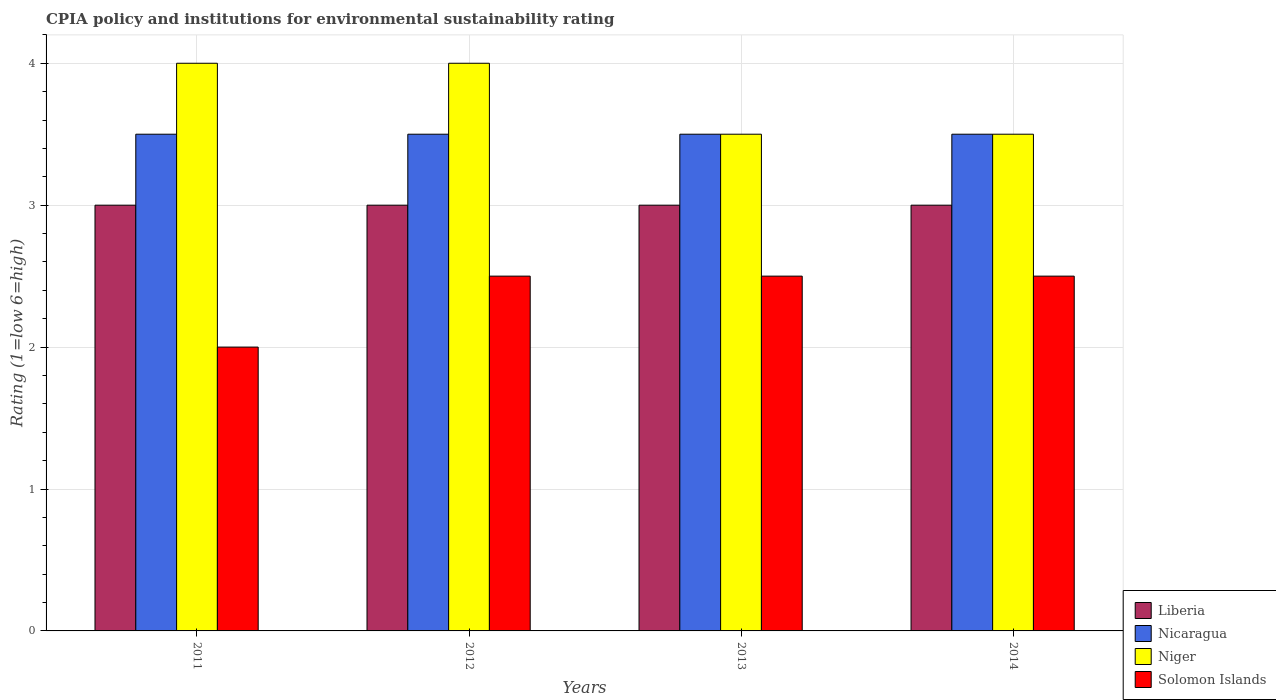How many different coloured bars are there?
Make the answer very short. 4. How many bars are there on the 4th tick from the left?
Keep it short and to the point. 4. What is the label of the 3rd group of bars from the left?
Offer a terse response. 2013. In how many cases, is the number of bars for a given year not equal to the number of legend labels?
Your answer should be compact. 0. What is the CPIA rating in Nicaragua in 2012?
Your answer should be very brief. 3.5. What is the average CPIA rating in Niger per year?
Keep it short and to the point. 3.75. What is the difference between the highest and the lowest CPIA rating in Solomon Islands?
Your response must be concise. 0.5. Is the sum of the CPIA rating in Solomon Islands in 2011 and 2013 greater than the maximum CPIA rating in Nicaragua across all years?
Offer a very short reply. Yes. What does the 3rd bar from the left in 2012 represents?
Your answer should be very brief. Niger. What does the 1st bar from the right in 2012 represents?
Offer a very short reply. Solomon Islands. How many years are there in the graph?
Give a very brief answer. 4. Are the values on the major ticks of Y-axis written in scientific E-notation?
Your answer should be very brief. No. How many legend labels are there?
Provide a short and direct response. 4. How are the legend labels stacked?
Provide a succinct answer. Vertical. What is the title of the graph?
Provide a succinct answer. CPIA policy and institutions for environmental sustainability rating. What is the label or title of the Y-axis?
Offer a terse response. Rating (1=low 6=high). What is the Rating (1=low 6=high) in Liberia in 2011?
Your answer should be compact. 3. What is the Rating (1=low 6=high) of Nicaragua in 2011?
Provide a short and direct response. 3.5. What is the Rating (1=low 6=high) in Nicaragua in 2012?
Keep it short and to the point. 3.5. What is the Rating (1=low 6=high) in Niger in 2012?
Your response must be concise. 4. What is the Rating (1=low 6=high) of Solomon Islands in 2012?
Provide a short and direct response. 2.5. What is the Rating (1=low 6=high) of Liberia in 2013?
Offer a terse response. 3. What is the Rating (1=low 6=high) in Nicaragua in 2013?
Your answer should be compact. 3.5. What is the Rating (1=low 6=high) in Niger in 2013?
Provide a succinct answer. 3.5. What is the Rating (1=low 6=high) of Nicaragua in 2014?
Make the answer very short. 3.5. What is the Rating (1=low 6=high) of Solomon Islands in 2014?
Ensure brevity in your answer.  2.5. Across all years, what is the maximum Rating (1=low 6=high) in Liberia?
Your answer should be very brief. 3. Across all years, what is the maximum Rating (1=low 6=high) in Niger?
Ensure brevity in your answer.  4. Across all years, what is the minimum Rating (1=low 6=high) of Nicaragua?
Keep it short and to the point. 3.5. What is the total Rating (1=low 6=high) in Niger in the graph?
Provide a succinct answer. 15. What is the total Rating (1=low 6=high) in Solomon Islands in the graph?
Offer a very short reply. 9.5. What is the difference between the Rating (1=low 6=high) of Liberia in 2011 and that in 2012?
Offer a terse response. 0. What is the difference between the Rating (1=low 6=high) of Solomon Islands in 2011 and that in 2012?
Make the answer very short. -0.5. What is the difference between the Rating (1=low 6=high) in Liberia in 2011 and that in 2013?
Provide a short and direct response. 0. What is the difference between the Rating (1=low 6=high) in Niger in 2011 and that in 2013?
Keep it short and to the point. 0.5. What is the difference between the Rating (1=low 6=high) in Liberia in 2011 and that in 2014?
Your answer should be very brief. 0. What is the difference between the Rating (1=low 6=high) in Niger in 2011 and that in 2014?
Your answer should be compact. 0.5. What is the difference between the Rating (1=low 6=high) of Liberia in 2012 and that in 2013?
Make the answer very short. 0. What is the difference between the Rating (1=low 6=high) in Nicaragua in 2012 and that in 2013?
Give a very brief answer. 0. What is the difference between the Rating (1=low 6=high) in Nicaragua in 2012 and that in 2014?
Make the answer very short. 0. What is the difference between the Rating (1=low 6=high) in Solomon Islands in 2012 and that in 2014?
Provide a succinct answer. 0. What is the difference between the Rating (1=low 6=high) in Liberia in 2011 and the Rating (1=low 6=high) in Niger in 2012?
Ensure brevity in your answer.  -1. What is the difference between the Rating (1=low 6=high) of Nicaragua in 2011 and the Rating (1=low 6=high) of Niger in 2012?
Your answer should be very brief. -0.5. What is the difference between the Rating (1=low 6=high) in Nicaragua in 2011 and the Rating (1=low 6=high) in Solomon Islands in 2012?
Keep it short and to the point. 1. What is the difference between the Rating (1=low 6=high) of Liberia in 2011 and the Rating (1=low 6=high) of Nicaragua in 2013?
Your answer should be very brief. -0.5. What is the difference between the Rating (1=low 6=high) in Liberia in 2011 and the Rating (1=low 6=high) in Solomon Islands in 2013?
Ensure brevity in your answer.  0.5. What is the difference between the Rating (1=low 6=high) in Nicaragua in 2011 and the Rating (1=low 6=high) in Solomon Islands in 2013?
Provide a short and direct response. 1. What is the difference between the Rating (1=low 6=high) of Niger in 2011 and the Rating (1=low 6=high) of Solomon Islands in 2013?
Offer a terse response. 1.5. What is the difference between the Rating (1=low 6=high) in Nicaragua in 2011 and the Rating (1=low 6=high) in Niger in 2014?
Your answer should be compact. 0. What is the difference between the Rating (1=low 6=high) of Nicaragua in 2011 and the Rating (1=low 6=high) of Solomon Islands in 2014?
Provide a short and direct response. 1. What is the difference between the Rating (1=low 6=high) of Niger in 2011 and the Rating (1=low 6=high) of Solomon Islands in 2014?
Offer a very short reply. 1.5. What is the difference between the Rating (1=low 6=high) of Liberia in 2012 and the Rating (1=low 6=high) of Solomon Islands in 2013?
Offer a very short reply. 0.5. What is the difference between the Rating (1=low 6=high) of Nicaragua in 2012 and the Rating (1=low 6=high) of Niger in 2013?
Keep it short and to the point. 0. What is the difference between the Rating (1=low 6=high) of Nicaragua in 2012 and the Rating (1=low 6=high) of Solomon Islands in 2013?
Offer a very short reply. 1. What is the difference between the Rating (1=low 6=high) in Liberia in 2012 and the Rating (1=low 6=high) in Niger in 2014?
Offer a very short reply. -0.5. What is the difference between the Rating (1=low 6=high) of Nicaragua in 2012 and the Rating (1=low 6=high) of Niger in 2014?
Offer a terse response. 0. What is the difference between the Rating (1=low 6=high) of Niger in 2012 and the Rating (1=low 6=high) of Solomon Islands in 2014?
Offer a terse response. 1.5. What is the difference between the Rating (1=low 6=high) in Liberia in 2013 and the Rating (1=low 6=high) in Niger in 2014?
Your answer should be very brief. -0.5. What is the average Rating (1=low 6=high) in Liberia per year?
Give a very brief answer. 3. What is the average Rating (1=low 6=high) of Niger per year?
Make the answer very short. 3.75. What is the average Rating (1=low 6=high) of Solomon Islands per year?
Give a very brief answer. 2.38. In the year 2011, what is the difference between the Rating (1=low 6=high) in Liberia and Rating (1=low 6=high) in Niger?
Your response must be concise. -1. In the year 2011, what is the difference between the Rating (1=low 6=high) of Liberia and Rating (1=low 6=high) of Solomon Islands?
Keep it short and to the point. 1. In the year 2011, what is the difference between the Rating (1=low 6=high) in Nicaragua and Rating (1=low 6=high) in Niger?
Make the answer very short. -0.5. In the year 2011, what is the difference between the Rating (1=low 6=high) in Nicaragua and Rating (1=low 6=high) in Solomon Islands?
Give a very brief answer. 1.5. In the year 2011, what is the difference between the Rating (1=low 6=high) of Niger and Rating (1=low 6=high) of Solomon Islands?
Make the answer very short. 2. In the year 2012, what is the difference between the Rating (1=low 6=high) of Liberia and Rating (1=low 6=high) of Nicaragua?
Ensure brevity in your answer.  -0.5. In the year 2012, what is the difference between the Rating (1=low 6=high) of Liberia and Rating (1=low 6=high) of Niger?
Provide a succinct answer. -1. In the year 2012, what is the difference between the Rating (1=low 6=high) of Nicaragua and Rating (1=low 6=high) of Solomon Islands?
Offer a very short reply. 1. In the year 2013, what is the difference between the Rating (1=low 6=high) of Liberia and Rating (1=low 6=high) of Nicaragua?
Make the answer very short. -0.5. In the year 2013, what is the difference between the Rating (1=low 6=high) of Nicaragua and Rating (1=low 6=high) of Niger?
Your answer should be very brief. 0. In the year 2013, what is the difference between the Rating (1=low 6=high) in Nicaragua and Rating (1=low 6=high) in Solomon Islands?
Provide a succinct answer. 1. In the year 2014, what is the difference between the Rating (1=low 6=high) of Liberia and Rating (1=low 6=high) of Nicaragua?
Offer a terse response. -0.5. In the year 2014, what is the difference between the Rating (1=low 6=high) of Liberia and Rating (1=low 6=high) of Solomon Islands?
Make the answer very short. 0.5. What is the ratio of the Rating (1=low 6=high) in Liberia in 2011 to that in 2012?
Provide a short and direct response. 1. What is the ratio of the Rating (1=low 6=high) in Nicaragua in 2011 to that in 2012?
Keep it short and to the point. 1. What is the ratio of the Rating (1=low 6=high) in Niger in 2011 to that in 2012?
Provide a succinct answer. 1. What is the ratio of the Rating (1=low 6=high) of Liberia in 2011 to that in 2013?
Your answer should be very brief. 1. What is the ratio of the Rating (1=low 6=high) in Niger in 2011 to that in 2013?
Keep it short and to the point. 1.14. What is the ratio of the Rating (1=low 6=high) of Nicaragua in 2011 to that in 2014?
Your answer should be very brief. 1. What is the ratio of the Rating (1=low 6=high) in Niger in 2011 to that in 2014?
Keep it short and to the point. 1.14. What is the ratio of the Rating (1=low 6=high) of Solomon Islands in 2011 to that in 2014?
Provide a succinct answer. 0.8. What is the ratio of the Rating (1=low 6=high) of Solomon Islands in 2012 to that in 2013?
Offer a very short reply. 1. What is the ratio of the Rating (1=low 6=high) in Niger in 2012 to that in 2014?
Provide a short and direct response. 1.14. What is the ratio of the Rating (1=low 6=high) in Niger in 2013 to that in 2014?
Offer a terse response. 1. What is the ratio of the Rating (1=low 6=high) of Solomon Islands in 2013 to that in 2014?
Offer a very short reply. 1. What is the difference between the highest and the second highest Rating (1=low 6=high) of Liberia?
Offer a very short reply. 0. What is the difference between the highest and the second highest Rating (1=low 6=high) in Nicaragua?
Offer a terse response. 0. What is the difference between the highest and the second highest Rating (1=low 6=high) of Niger?
Your answer should be compact. 0. What is the difference between the highest and the second highest Rating (1=low 6=high) in Solomon Islands?
Provide a short and direct response. 0. What is the difference between the highest and the lowest Rating (1=low 6=high) of Niger?
Your answer should be very brief. 0.5. 